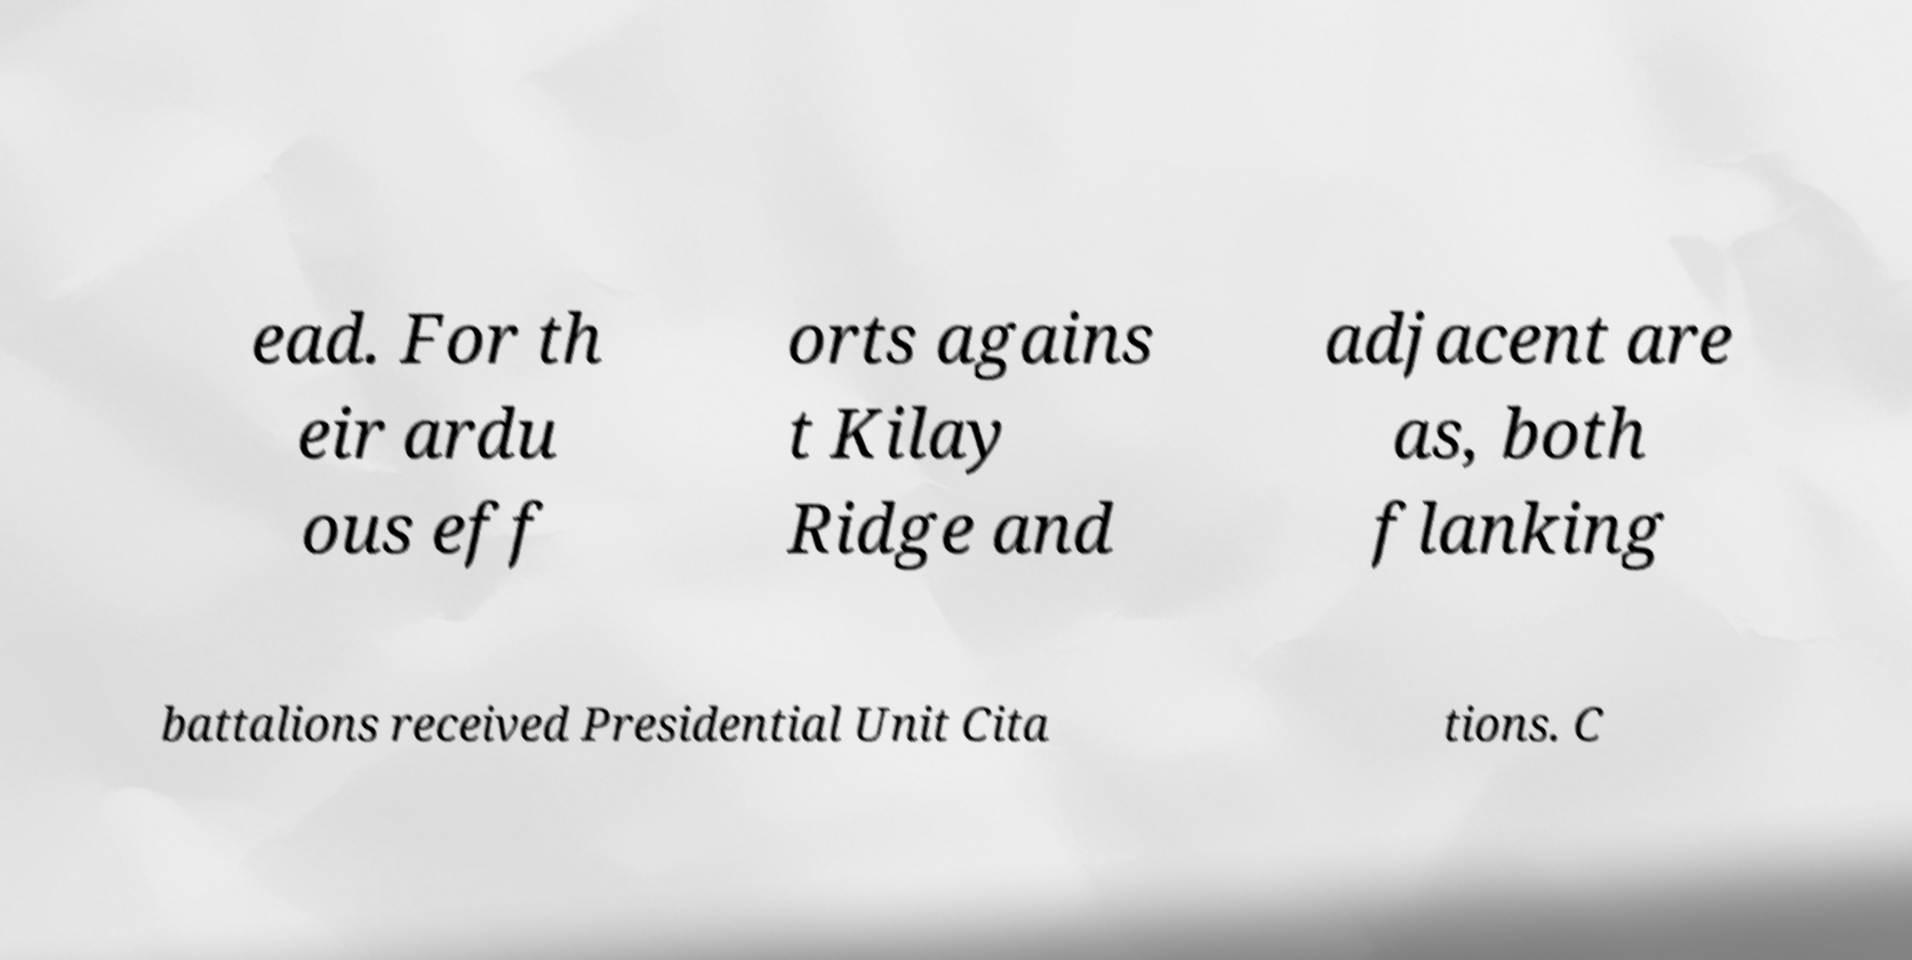What messages or text are displayed in this image? I need them in a readable, typed format. ead. For th eir ardu ous eff orts agains t Kilay Ridge and adjacent are as, both flanking battalions received Presidential Unit Cita tions. C 